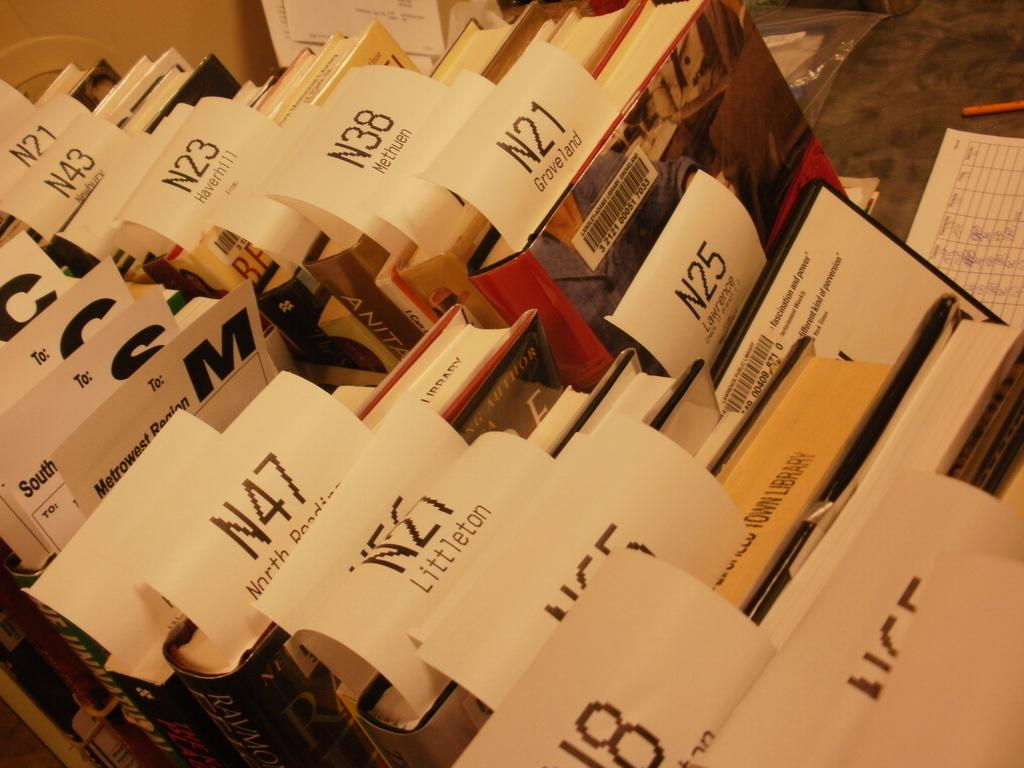Provide a one-sentence caption for the provided image. Books that are all Numbered with the letter N and a different number on each book. 